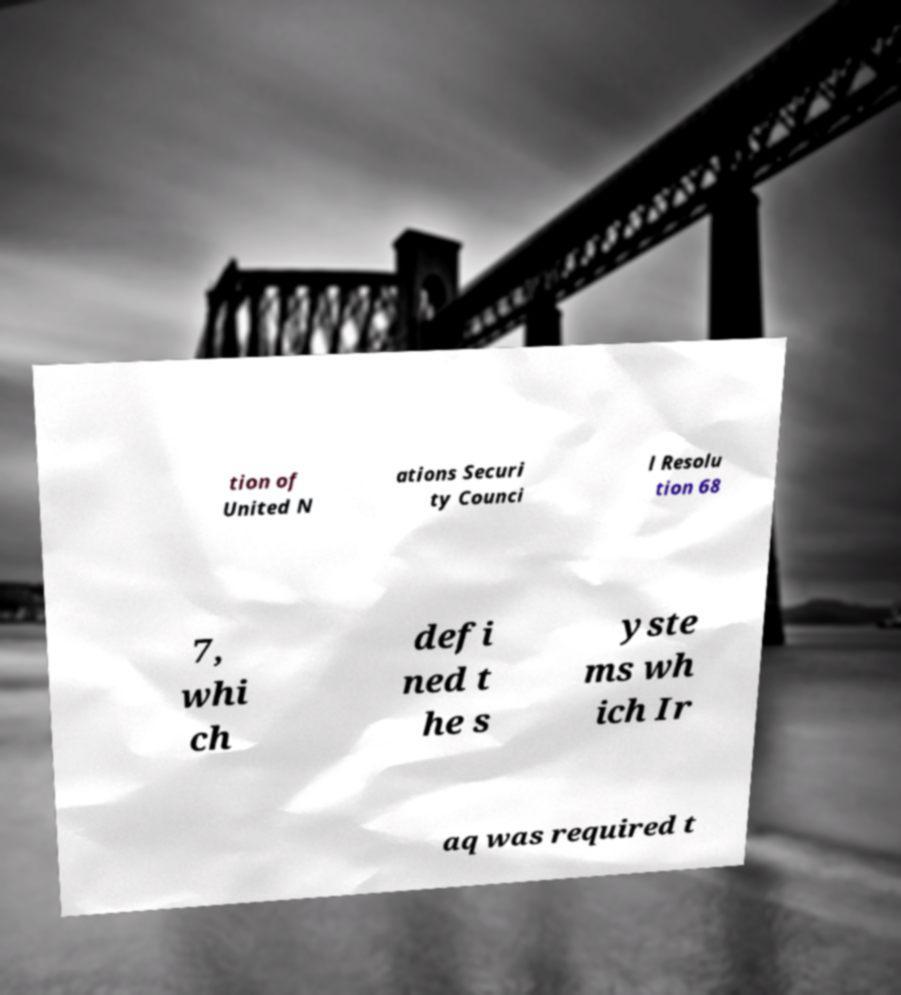What messages or text are displayed in this image? I need them in a readable, typed format. tion of United N ations Securi ty Counci l Resolu tion 68 7, whi ch defi ned t he s yste ms wh ich Ir aq was required t 